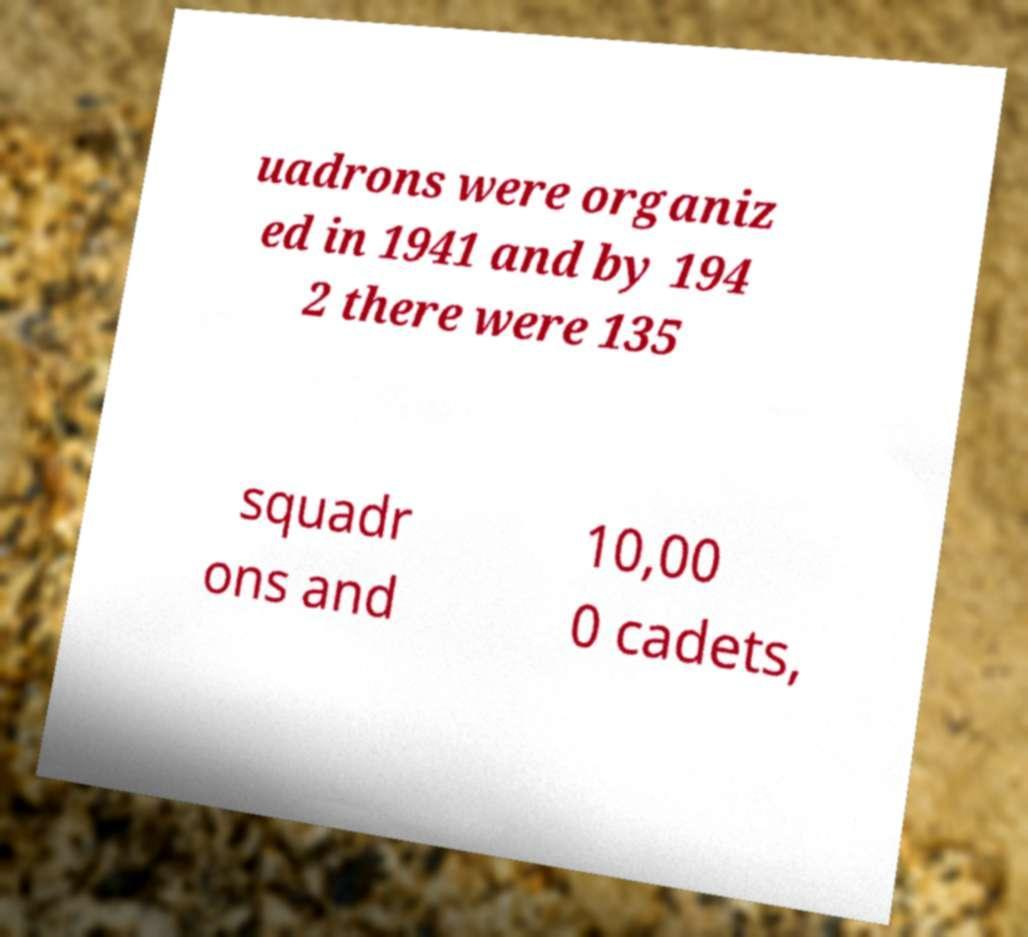Can you read and provide the text displayed in the image?This photo seems to have some interesting text. Can you extract and type it out for me? uadrons were organiz ed in 1941 and by 194 2 there were 135 squadr ons and 10,00 0 cadets, 